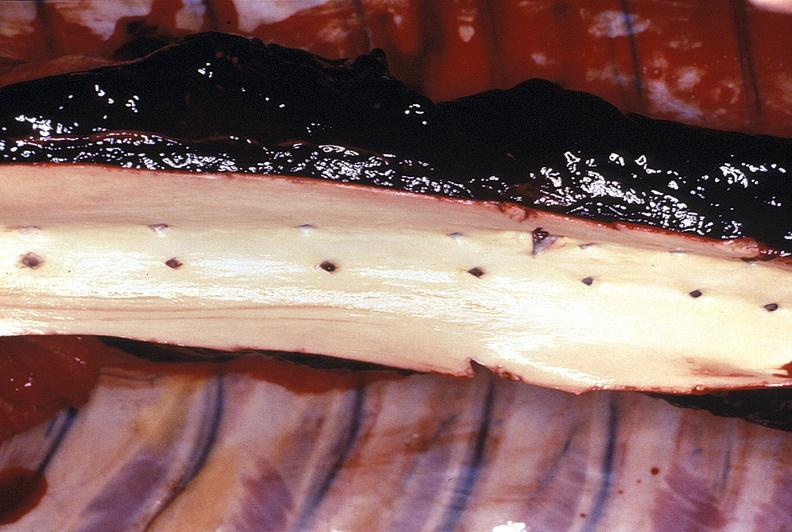s vasculature present?
Answer the question using a single word or phrase. Yes 